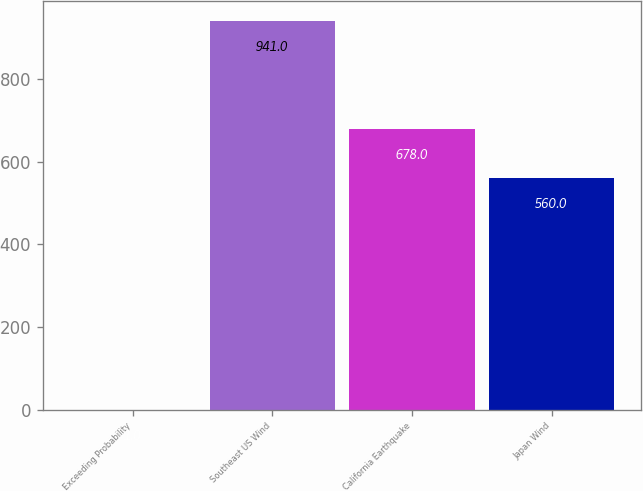<chart> <loc_0><loc_0><loc_500><loc_500><bar_chart><fcel>Exceeding Probability<fcel>Southeast US Wind<fcel>California Earthquake<fcel>Japan Wind<nl><fcel>1<fcel>941<fcel>678<fcel>560<nl></chart> 